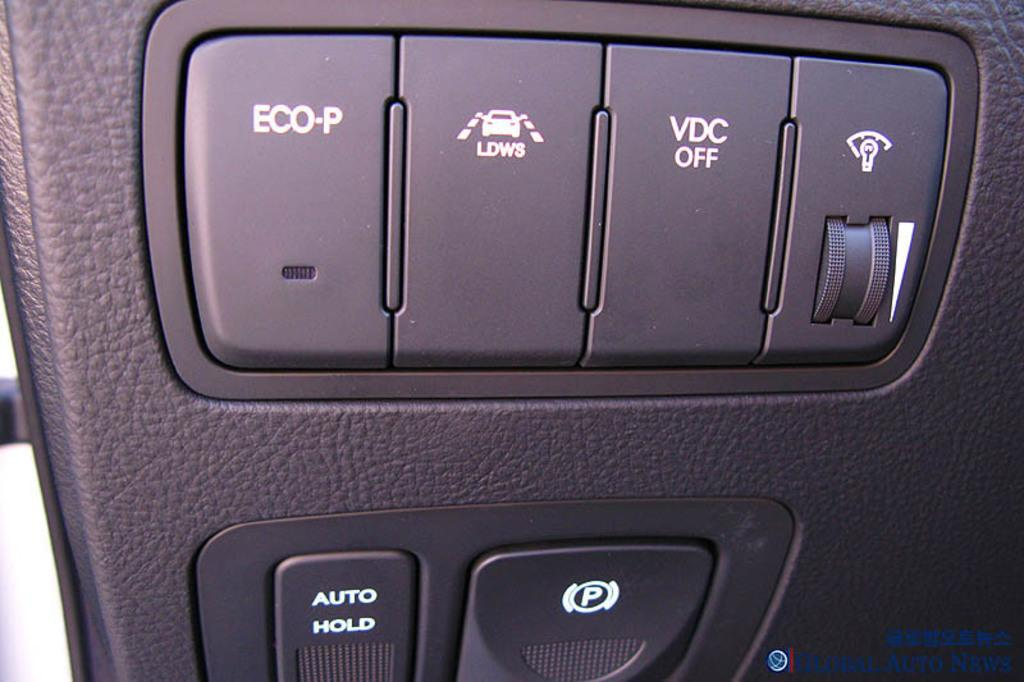What type of object can be seen in the image that resembles a vehicle part? There is an object in the image that resembles a vehicle part. What else is present in the image besides the vehicle part? There is text and symbols in the image. What type of breakfast is being served in the image? There is no breakfast present in the image; it features an object resembling a vehicle part, text, and symbols. In which direction is the judge facing in the image? There is no judge present in the image. 